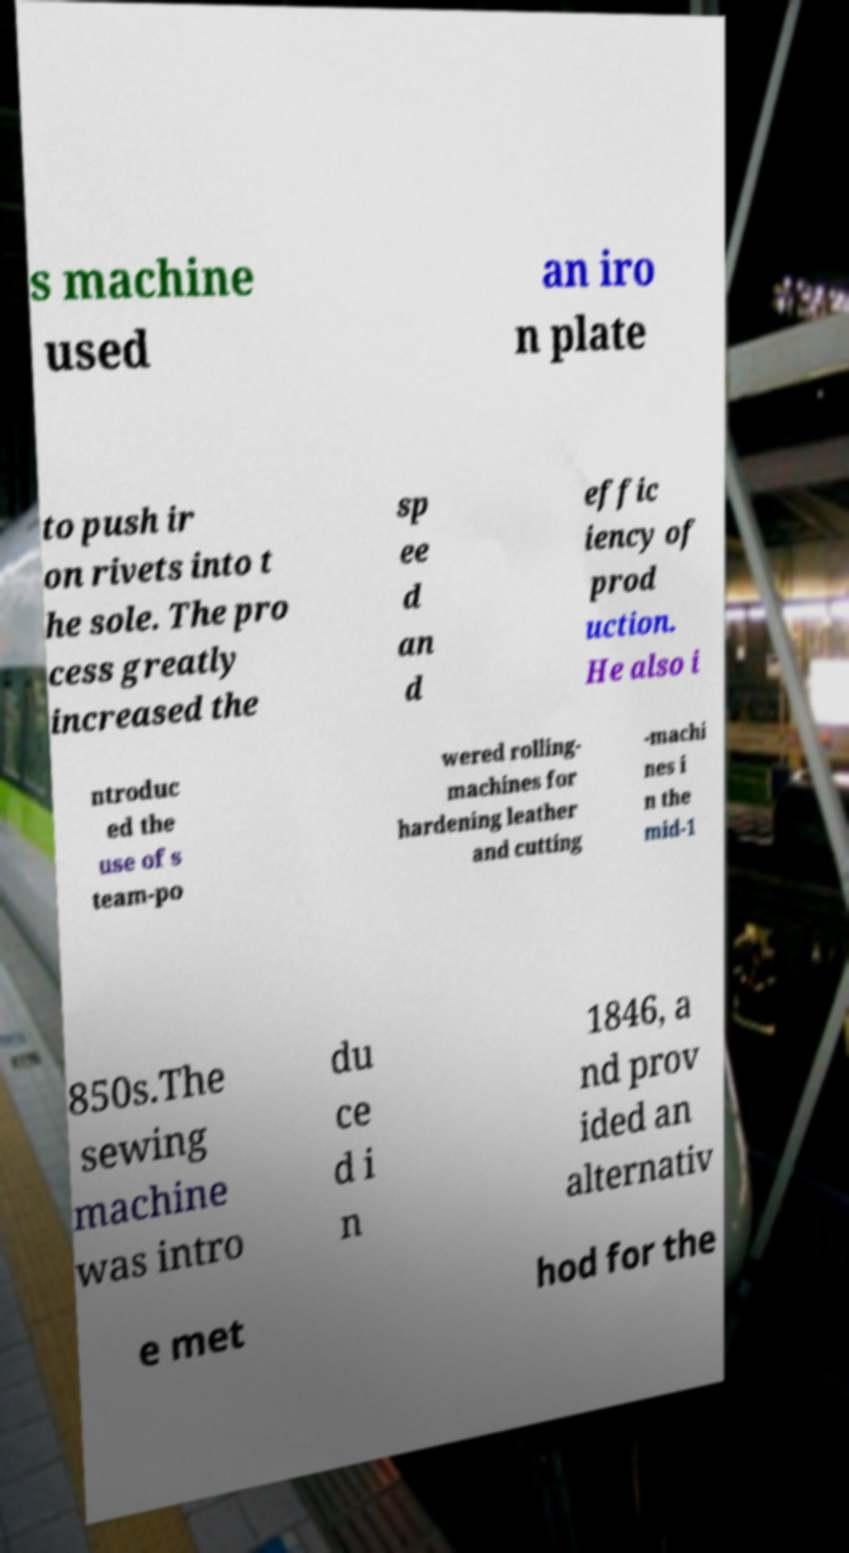Please identify and transcribe the text found in this image. s machine used an iro n plate to push ir on rivets into t he sole. The pro cess greatly increased the sp ee d an d effic iency of prod uction. He also i ntroduc ed the use of s team-po wered rolling- machines for hardening leather and cutting -machi nes i n the mid-1 850s.The sewing machine was intro du ce d i n 1846, a nd prov ided an alternativ e met hod for the 